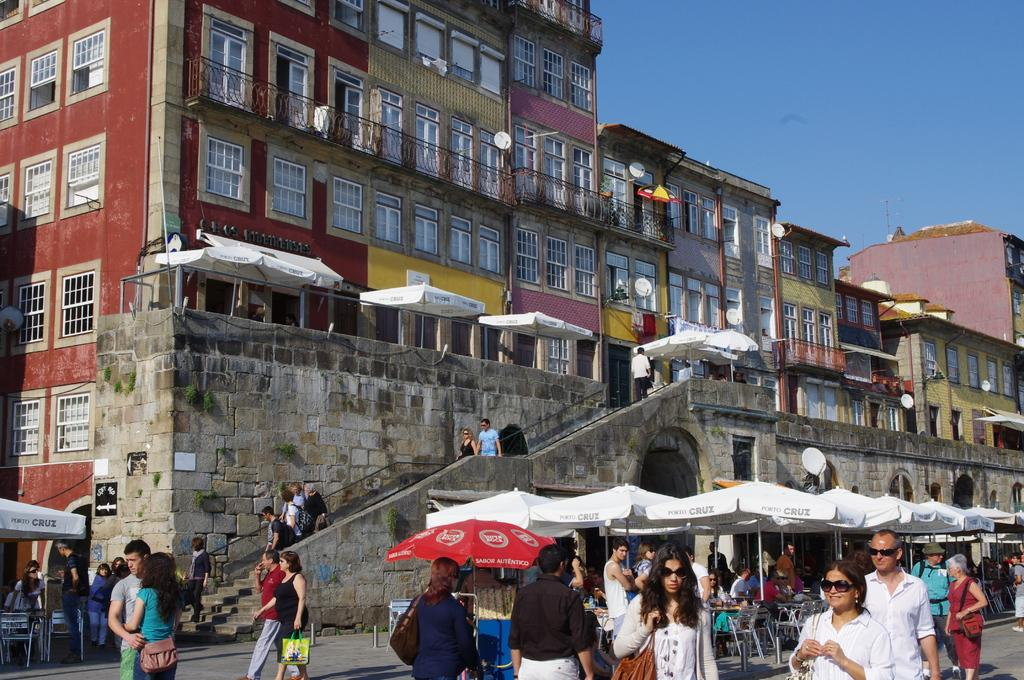What is the main subject of the image? The main subject of the image is a group of people standing. What objects are associated with the people in the image? Umbrellas attached to poles are visible in the image. What type of furniture is present in the image? There are chairs and tables in the image. What structures can be seen in the background of the image? Buildings are visible in the image. What type of communication devices are present in the image? Antennas are visible in the image. What part of the natural environment is visible in the image? The sky is visible in the image. What type of operation is being performed on the box in the image? There is no box present in the image, and therefore no operation can be observed. 